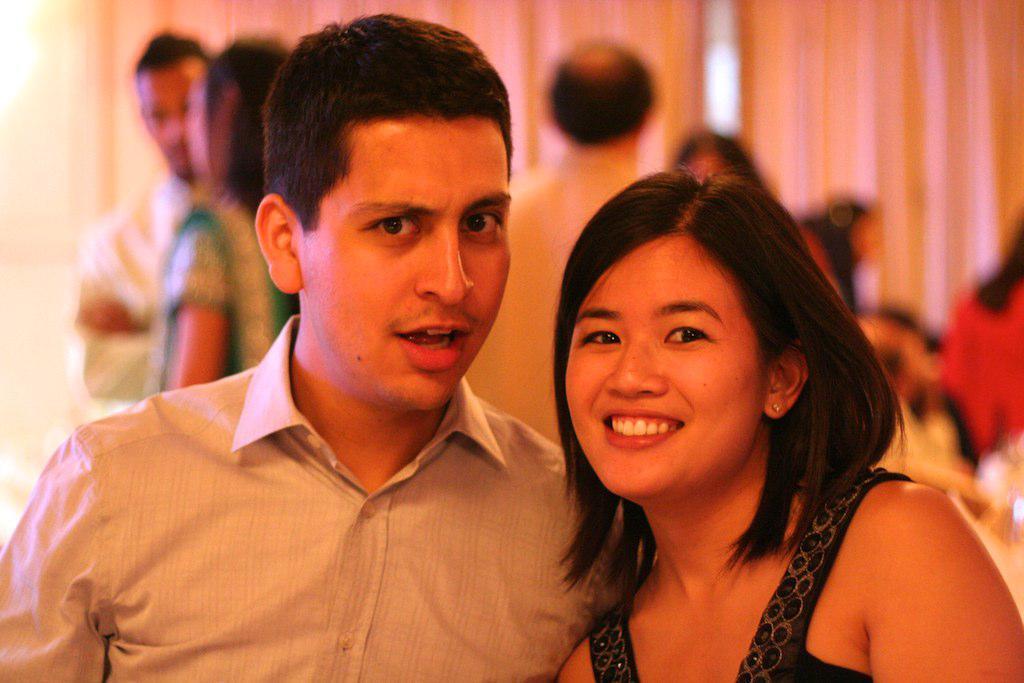How would you summarize this image in a sentence or two? This image is taken indoors. In the background there are two curtains and a few people are standing. In the middle of the image there is a man and a woman with smiling faces. 